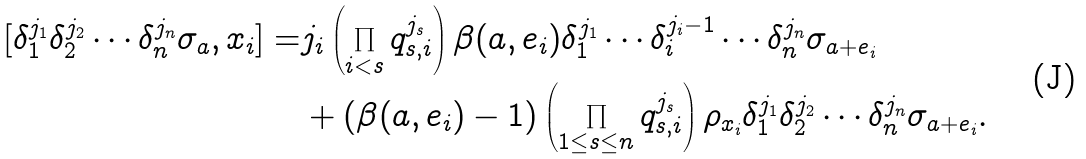<formula> <loc_0><loc_0><loc_500><loc_500>[ \delta _ { 1 } ^ { j _ { 1 } } \delta _ { 2 } ^ { j _ { 2 } } \cdots \delta _ { n } ^ { j _ { n } } \sigma _ { a } , x _ { i } ] = & j _ { i } \left ( \prod _ { i < s } q _ { s , i } ^ { j _ { s } } \right ) \beta ( a , e _ { i } ) \delta _ { 1 } ^ { j _ { 1 } } \cdots \delta _ { i } ^ { j _ { i } - 1 } \cdots \delta _ { n } ^ { j _ { n } } \sigma _ { a + e _ { i } } \\ & + ( \beta ( a , e _ { i } ) - 1 ) \left ( \prod _ { 1 \leq s \leq n } q _ { s , i } ^ { j _ { s } } \right ) \rho _ { x _ { i } } \delta _ { 1 } ^ { j _ { 1 } } \delta _ { 2 } ^ { j _ { 2 } } \cdots \delta _ { n } ^ { j _ { n } } \sigma _ { a + e _ { i } } .</formula> 